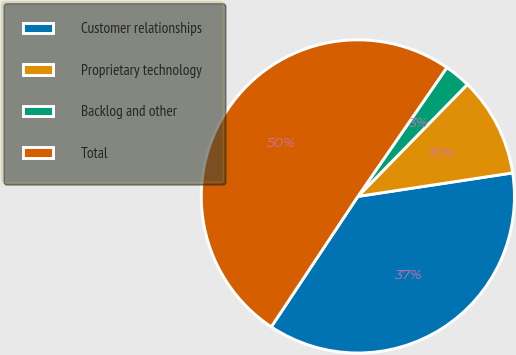<chart> <loc_0><loc_0><loc_500><loc_500><pie_chart><fcel>Customer relationships<fcel>Proprietary technology<fcel>Backlog and other<fcel>Total<nl><fcel>36.73%<fcel>10.28%<fcel>2.7%<fcel>50.29%<nl></chart> 